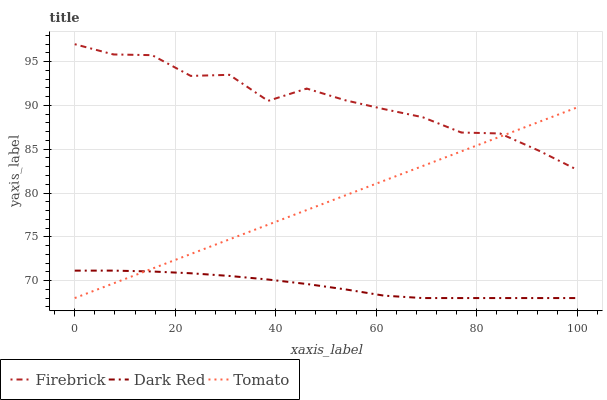Does Dark Red have the minimum area under the curve?
Answer yes or no. Yes. Does Firebrick have the maximum area under the curve?
Answer yes or no. Yes. Does Firebrick have the minimum area under the curve?
Answer yes or no. No. Does Dark Red have the maximum area under the curve?
Answer yes or no. No. Is Tomato the smoothest?
Answer yes or no. Yes. Is Firebrick the roughest?
Answer yes or no. Yes. Is Dark Red the smoothest?
Answer yes or no. No. Is Dark Red the roughest?
Answer yes or no. No. Does Tomato have the lowest value?
Answer yes or no. Yes. Does Firebrick have the lowest value?
Answer yes or no. No. Does Firebrick have the highest value?
Answer yes or no. Yes. Does Dark Red have the highest value?
Answer yes or no. No. Is Dark Red less than Firebrick?
Answer yes or no. Yes. Is Firebrick greater than Dark Red?
Answer yes or no. Yes. Does Tomato intersect Dark Red?
Answer yes or no. Yes. Is Tomato less than Dark Red?
Answer yes or no. No. Is Tomato greater than Dark Red?
Answer yes or no. No. Does Dark Red intersect Firebrick?
Answer yes or no. No. 